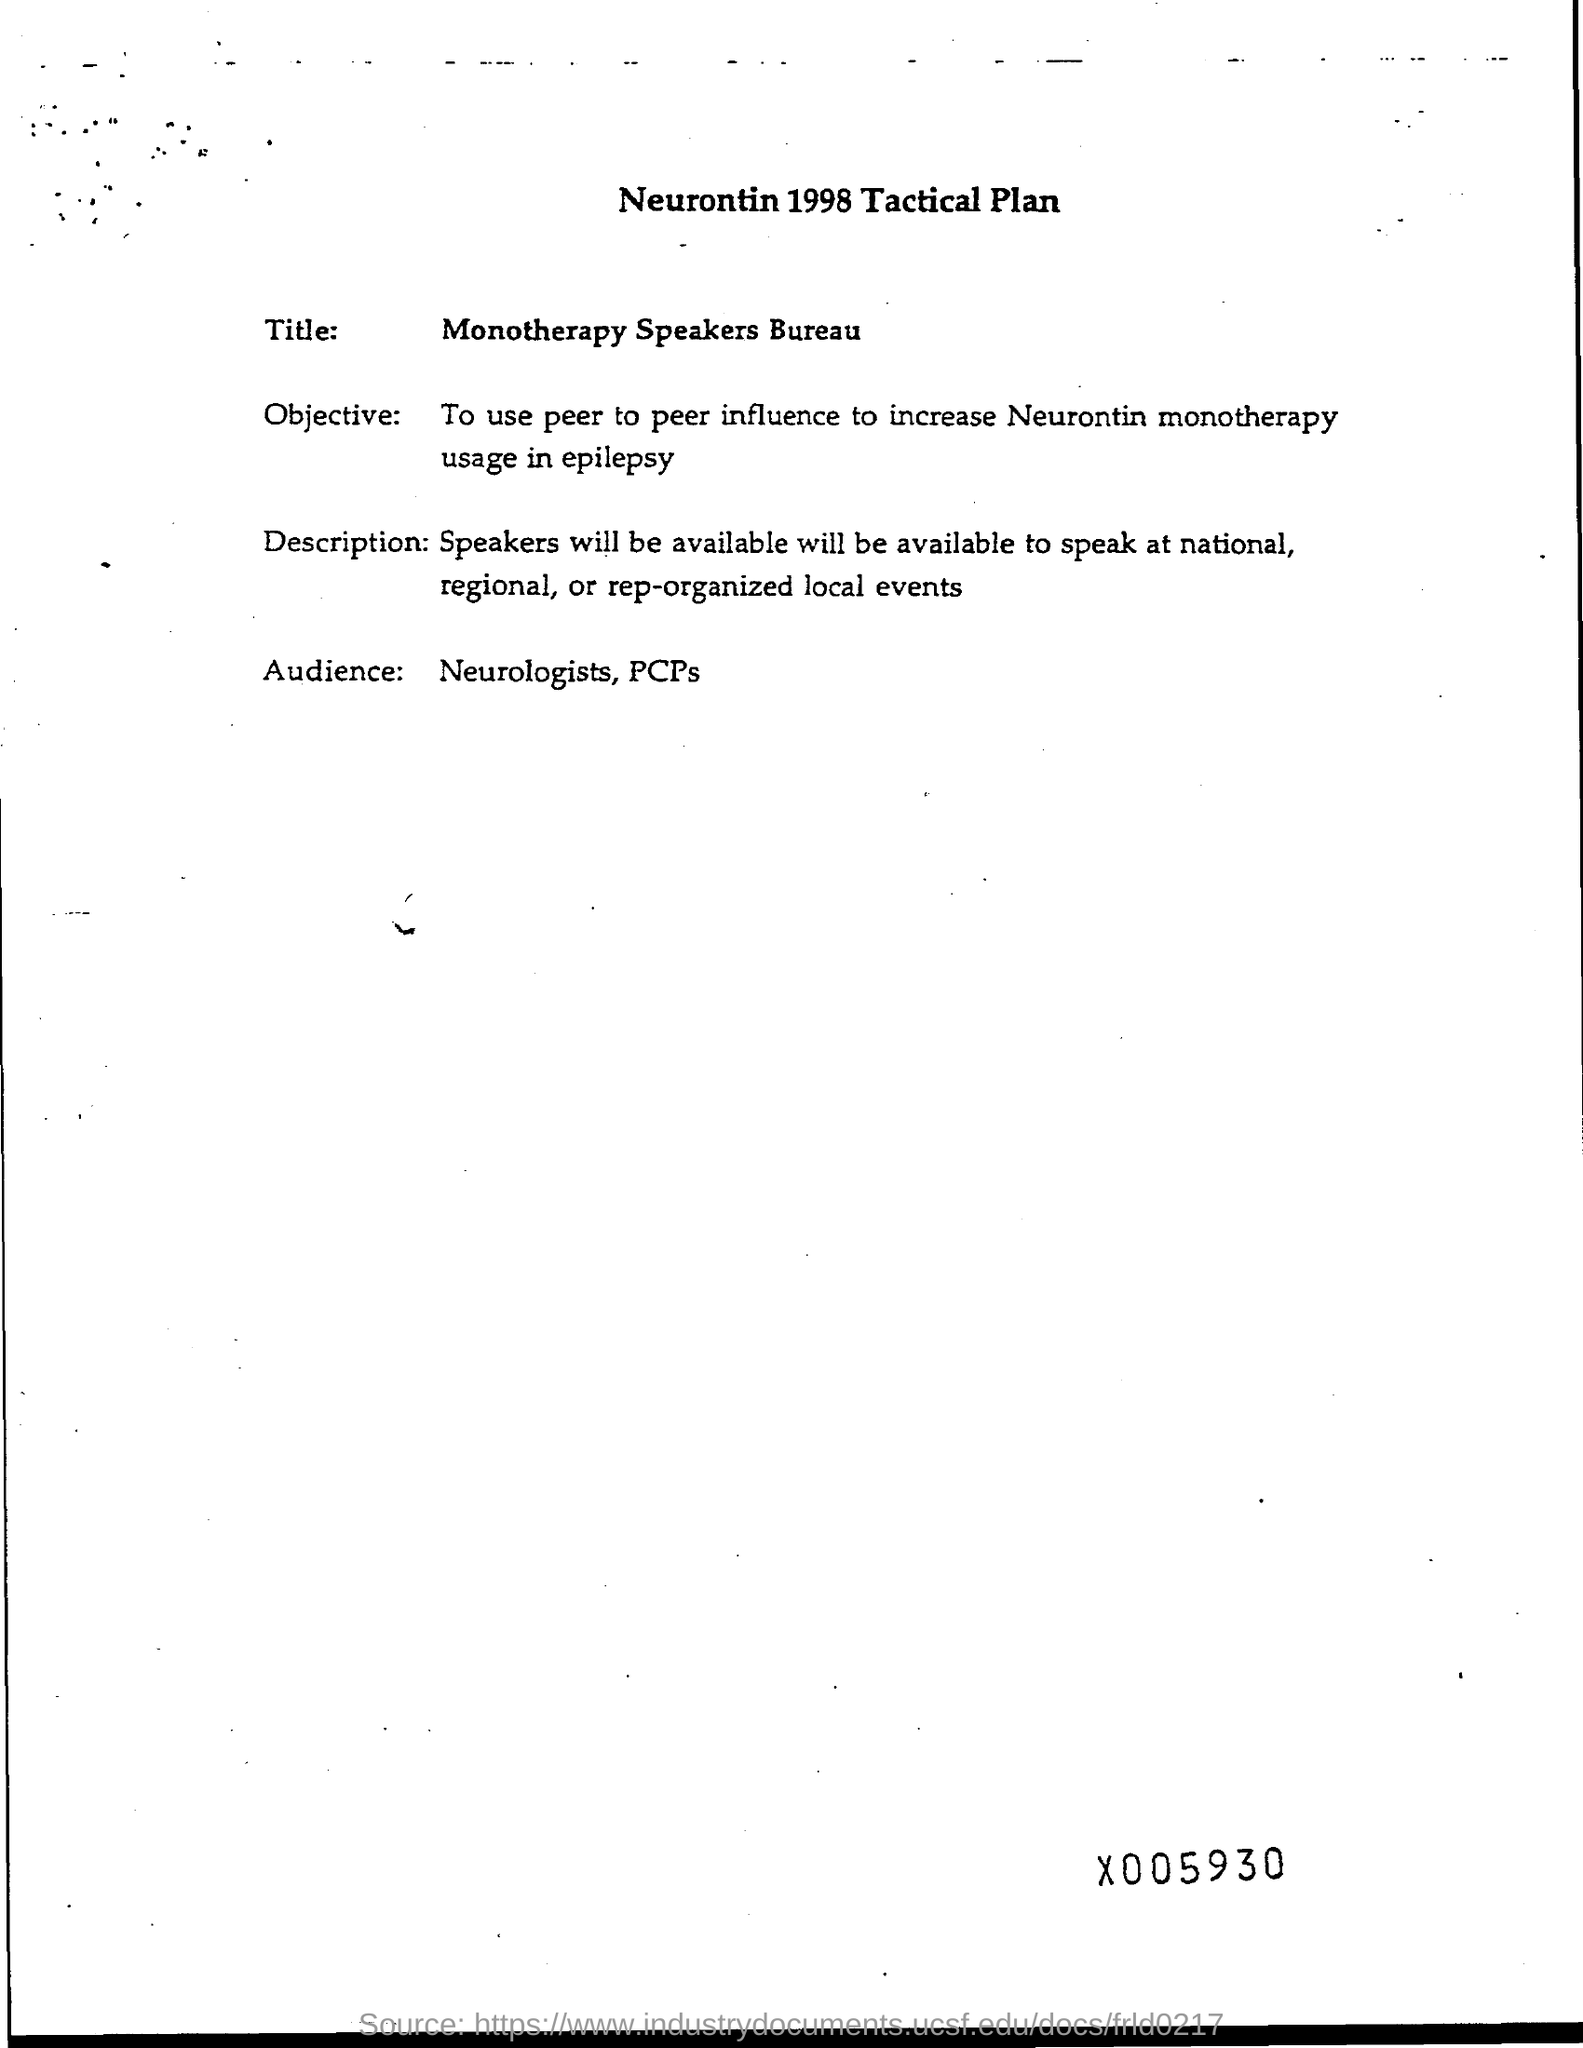Draw attention to some important aspects in this diagram. The heading at the top of the page is the tactical plan from 1998 for Neurontin. The intended audience for the neurologists and primary care physicians (PCPs) is those individuals who have experienced neurological symptoms. 